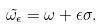<formula> <loc_0><loc_0><loc_500><loc_500>\tilde { \omega _ { \epsilon } } = \omega + \epsilon \sigma .</formula> 